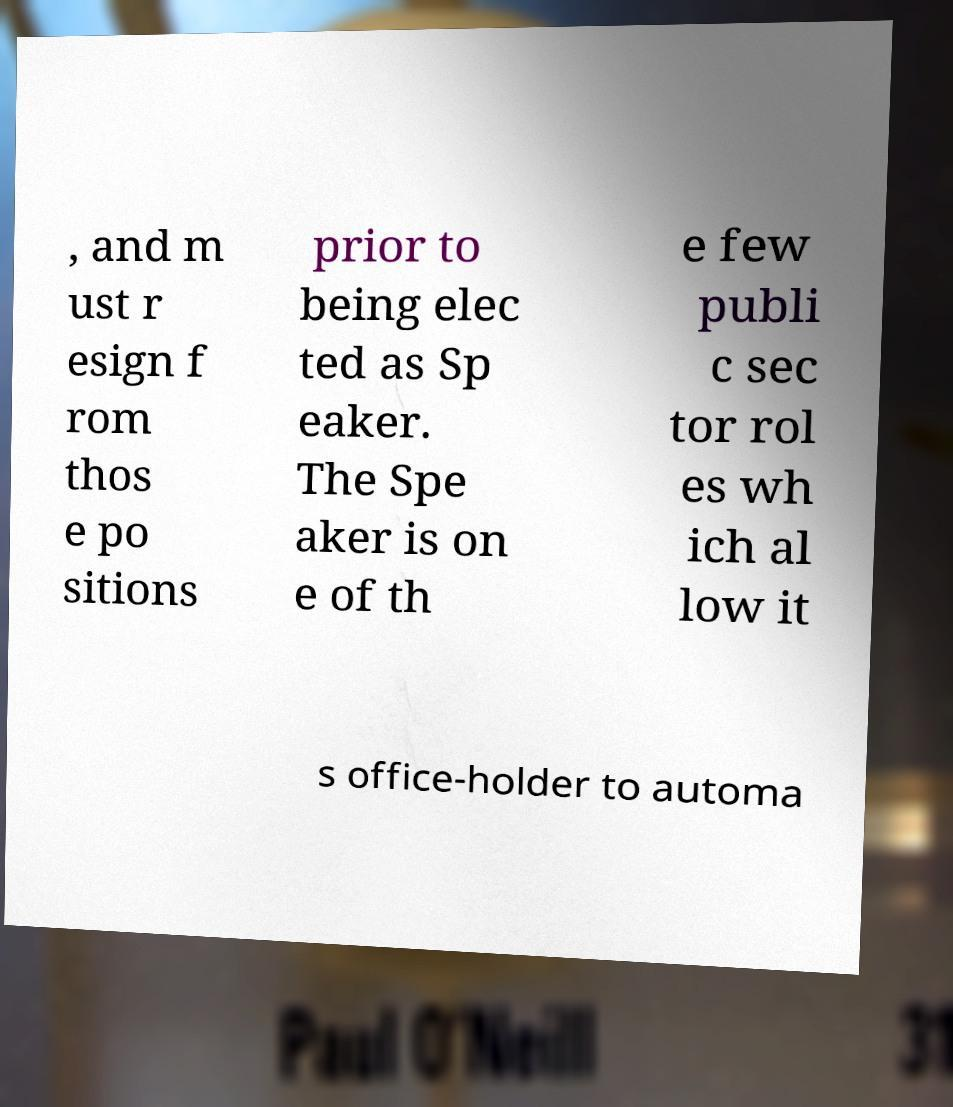Please identify and transcribe the text found in this image. , and m ust r esign f rom thos e po sitions prior to being elec ted as Sp eaker. The Spe aker is on e of th e few publi c sec tor rol es wh ich al low it s office-holder to automa 